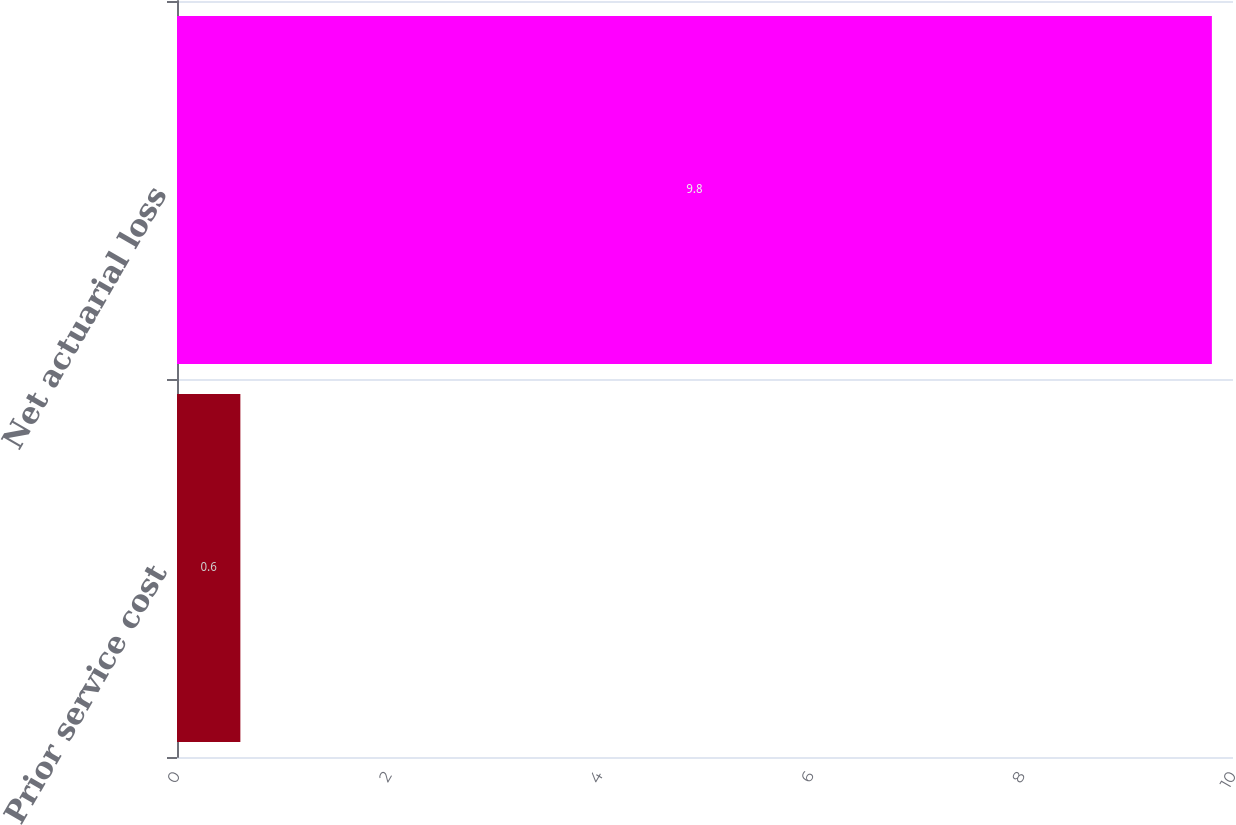Convert chart. <chart><loc_0><loc_0><loc_500><loc_500><bar_chart><fcel>Prior service cost<fcel>Net actuarial loss<nl><fcel>0.6<fcel>9.8<nl></chart> 